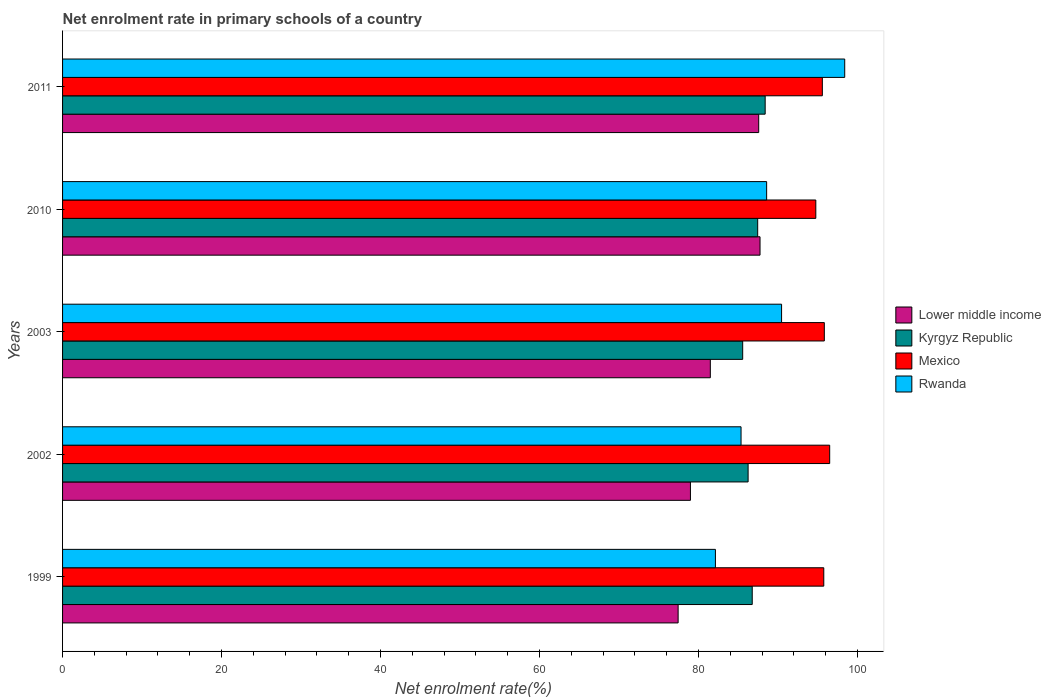Are the number of bars on each tick of the Y-axis equal?
Give a very brief answer. Yes. How many bars are there on the 5th tick from the top?
Keep it short and to the point. 4. How many bars are there on the 4th tick from the bottom?
Keep it short and to the point. 4. What is the label of the 1st group of bars from the top?
Keep it short and to the point. 2011. What is the net enrolment rate in primary schools in Rwanda in 2010?
Offer a very short reply. 88.57. Across all years, what is the maximum net enrolment rate in primary schools in Lower middle income?
Provide a short and direct response. 87.74. Across all years, what is the minimum net enrolment rate in primary schools in Lower middle income?
Keep it short and to the point. 77.44. In which year was the net enrolment rate in primary schools in Kyrgyz Republic maximum?
Ensure brevity in your answer.  2011. What is the total net enrolment rate in primary schools in Kyrgyz Republic in the graph?
Your answer should be very brief. 434.4. What is the difference between the net enrolment rate in primary schools in Kyrgyz Republic in 1999 and that in 2002?
Your response must be concise. 0.52. What is the difference between the net enrolment rate in primary schools in Rwanda in 1999 and the net enrolment rate in primary schools in Mexico in 2003?
Make the answer very short. -13.7. What is the average net enrolment rate in primary schools in Kyrgyz Republic per year?
Keep it short and to the point. 86.88. In the year 1999, what is the difference between the net enrolment rate in primary schools in Mexico and net enrolment rate in primary schools in Kyrgyz Republic?
Keep it short and to the point. 9. What is the ratio of the net enrolment rate in primary schools in Mexico in 1999 to that in 2010?
Make the answer very short. 1.01. Is the difference between the net enrolment rate in primary schools in Mexico in 2003 and 2011 greater than the difference between the net enrolment rate in primary schools in Kyrgyz Republic in 2003 and 2011?
Your answer should be compact. Yes. What is the difference between the highest and the second highest net enrolment rate in primary schools in Mexico?
Make the answer very short. 0.68. What is the difference between the highest and the lowest net enrolment rate in primary schools in Rwanda?
Give a very brief answer. 16.26. In how many years, is the net enrolment rate in primary schools in Lower middle income greater than the average net enrolment rate in primary schools in Lower middle income taken over all years?
Give a very brief answer. 2. What does the 1st bar from the top in 2010 represents?
Ensure brevity in your answer.  Rwanda. What does the 3rd bar from the bottom in 2003 represents?
Offer a terse response. Mexico. Are all the bars in the graph horizontal?
Offer a very short reply. Yes. What is the difference between two consecutive major ticks on the X-axis?
Give a very brief answer. 20. Does the graph contain grids?
Offer a terse response. No. Where does the legend appear in the graph?
Offer a terse response. Center right. How many legend labels are there?
Offer a very short reply. 4. How are the legend labels stacked?
Provide a short and direct response. Vertical. What is the title of the graph?
Offer a very short reply. Net enrolment rate in primary schools of a country. What is the label or title of the X-axis?
Your answer should be compact. Net enrolment rate(%). What is the label or title of the Y-axis?
Your answer should be compact. Years. What is the Net enrolment rate(%) in Lower middle income in 1999?
Ensure brevity in your answer.  77.44. What is the Net enrolment rate(%) of Kyrgyz Republic in 1999?
Ensure brevity in your answer.  86.76. What is the Net enrolment rate(%) of Mexico in 1999?
Offer a terse response. 95.76. What is the Net enrolment rate(%) in Rwanda in 1999?
Provide a short and direct response. 82.13. What is the Net enrolment rate(%) in Lower middle income in 2002?
Your response must be concise. 78.99. What is the Net enrolment rate(%) in Kyrgyz Republic in 2002?
Your response must be concise. 86.24. What is the Net enrolment rate(%) in Mexico in 2002?
Your response must be concise. 96.51. What is the Net enrolment rate(%) in Rwanda in 2002?
Offer a very short reply. 85.35. What is the Net enrolment rate(%) in Lower middle income in 2003?
Provide a succinct answer. 81.49. What is the Net enrolment rate(%) of Kyrgyz Republic in 2003?
Give a very brief answer. 85.56. What is the Net enrolment rate(%) in Mexico in 2003?
Give a very brief answer. 95.83. What is the Net enrolment rate(%) in Rwanda in 2003?
Your answer should be compact. 90.45. What is the Net enrolment rate(%) of Lower middle income in 2010?
Offer a very short reply. 87.74. What is the Net enrolment rate(%) in Kyrgyz Republic in 2010?
Ensure brevity in your answer.  87.45. What is the Net enrolment rate(%) in Mexico in 2010?
Ensure brevity in your answer.  94.76. What is the Net enrolment rate(%) of Rwanda in 2010?
Your answer should be very brief. 88.57. What is the Net enrolment rate(%) in Lower middle income in 2011?
Your answer should be very brief. 87.57. What is the Net enrolment rate(%) of Kyrgyz Republic in 2011?
Provide a succinct answer. 88.39. What is the Net enrolment rate(%) of Mexico in 2011?
Your response must be concise. 95.58. What is the Net enrolment rate(%) of Rwanda in 2011?
Keep it short and to the point. 98.39. Across all years, what is the maximum Net enrolment rate(%) in Lower middle income?
Your answer should be very brief. 87.74. Across all years, what is the maximum Net enrolment rate(%) in Kyrgyz Republic?
Keep it short and to the point. 88.39. Across all years, what is the maximum Net enrolment rate(%) in Mexico?
Provide a succinct answer. 96.51. Across all years, what is the maximum Net enrolment rate(%) in Rwanda?
Ensure brevity in your answer.  98.39. Across all years, what is the minimum Net enrolment rate(%) in Lower middle income?
Offer a very short reply. 77.44. Across all years, what is the minimum Net enrolment rate(%) of Kyrgyz Republic?
Make the answer very short. 85.56. Across all years, what is the minimum Net enrolment rate(%) of Mexico?
Offer a very short reply. 94.76. Across all years, what is the minimum Net enrolment rate(%) in Rwanda?
Your answer should be very brief. 82.13. What is the total Net enrolment rate(%) in Lower middle income in the graph?
Offer a terse response. 413.23. What is the total Net enrolment rate(%) in Kyrgyz Republic in the graph?
Offer a very short reply. 434.4. What is the total Net enrolment rate(%) in Mexico in the graph?
Provide a short and direct response. 478.44. What is the total Net enrolment rate(%) of Rwanda in the graph?
Give a very brief answer. 444.91. What is the difference between the Net enrolment rate(%) of Lower middle income in 1999 and that in 2002?
Your answer should be compact. -1.55. What is the difference between the Net enrolment rate(%) of Kyrgyz Republic in 1999 and that in 2002?
Offer a very short reply. 0.52. What is the difference between the Net enrolment rate(%) in Mexico in 1999 and that in 2002?
Offer a terse response. -0.74. What is the difference between the Net enrolment rate(%) in Rwanda in 1999 and that in 2002?
Offer a terse response. -3.22. What is the difference between the Net enrolment rate(%) of Lower middle income in 1999 and that in 2003?
Offer a very short reply. -4.05. What is the difference between the Net enrolment rate(%) in Kyrgyz Republic in 1999 and that in 2003?
Keep it short and to the point. 1.2. What is the difference between the Net enrolment rate(%) in Mexico in 1999 and that in 2003?
Make the answer very short. -0.07. What is the difference between the Net enrolment rate(%) in Rwanda in 1999 and that in 2003?
Your answer should be very brief. -8.32. What is the difference between the Net enrolment rate(%) of Lower middle income in 1999 and that in 2010?
Your answer should be very brief. -10.3. What is the difference between the Net enrolment rate(%) of Kyrgyz Republic in 1999 and that in 2010?
Your answer should be very brief. -0.69. What is the difference between the Net enrolment rate(%) of Rwanda in 1999 and that in 2010?
Offer a terse response. -6.44. What is the difference between the Net enrolment rate(%) in Lower middle income in 1999 and that in 2011?
Your answer should be very brief. -10.14. What is the difference between the Net enrolment rate(%) in Kyrgyz Republic in 1999 and that in 2011?
Provide a succinct answer. -1.63. What is the difference between the Net enrolment rate(%) of Mexico in 1999 and that in 2011?
Offer a terse response. 0.18. What is the difference between the Net enrolment rate(%) in Rwanda in 1999 and that in 2011?
Offer a terse response. -16.26. What is the difference between the Net enrolment rate(%) in Lower middle income in 2002 and that in 2003?
Your answer should be very brief. -2.5. What is the difference between the Net enrolment rate(%) in Kyrgyz Republic in 2002 and that in 2003?
Your answer should be compact. 0.68. What is the difference between the Net enrolment rate(%) in Mexico in 2002 and that in 2003?
Provide a short and direct response. 0.68. What is the difference between the Net enrolment rate(%) of Rwanda in 2002 and that in 2003?
Offer a very short reply. -5.1. What is the difference between the Net enrolment rate(%) of Lower middle income in 2002 and that in 2010?
Your answer should be compact. -8.76. What is the difference between the Net enrolment rate(%) in Kyrgyz Republic in 2002 and that in 2010?
Ensure brevity in your answer.  -1.21. What is the difference between the Net enrolment rate(%) of Mexico in 2002 and that in 2010?
Give a very brief answer. 1.75. What is the difference between the Net enrolment rate(%) in Rwanda in 2002 and that in 2010?
Offer a terse response. -3.22. What is the difference between the Net enrolment rate(%) in Lower middle income in 2002 and that in 2011?
Your answer should be very brief. -8.59. What is the difference between the Net enrolment rate(%) in Kyrgyz Republic in 2002 and that in 2011?
Ensure brevity in your answer.  -2.15. What is the difference between the Net enrolment rate(%) in Mexico in 2002 and that in 2011?
Keep it short and to the point. 0.92. What is the difference between the Net enrolment rate(%) of Rwanda in 2002 and that in 2011?
Offer a very short reply. -13.04. What is the difference between the Net enrolment rate(%) of Lower middle income in 2003 and that in 2010?
Provide a succinct answer. -6.25. What is the difference between the Net enrolment rate(%) of Kyrgyz Republic in 2003 and that in 2010?
Your response must be concise. -1.89. What is the difference between the Net enrolment rate(%) of Mexico in 2003 and that in 2010?
Offer a terse response. 1.07. What is the difference between the Net enrolment rate(%) of Rwanda in 2003 and that in 2010?
Offer a very short reply. 1.88. What is the difference between the Net enrolment rate(%) in Lower middle income in 2003 and that in 2011?
Provide a short and direct response. -6.08. What is the difference between the Net enrolment rate(%) of Kyrgyz Republic in 2003 and that in 2011?
Keep it short and to the point. -2.83. What is the difference between the Net enrolment rate(%) in Mexico in 2003 and that in 2011?
Offer a terse response. 0.25. What is the difference between the Net enrolment rate(%) in Rwanda in 2003 and that in 2011?
Your answer should be very brief. -7.94. What is the difference between the Net enrolment rate(%) in Lower middle income in 2010 and that in 2011?
Provide a short and direct response. 0.17. What is the difference between the Net enrolment rate(%) of Kyrgyz Republic in 2010 and that in 2011?
Make the answer very short. -0.94. What is the difference between the Net enrolment rate(%) in Mexico in 2010 and that in 2011?
Offer a terse response. -0.82. What is the difference between the Net enrolment rate(%) of Rwanda in 2010 and that in 2011?
Make the answer very short. -9.82. What is the difference between the Net enrolment rate(%) of Lower middle income in 1999 and the Net enrolment rate(%) of Kyrgyz Republic in 2002?
Provide a short and direct response. -8.8. What is the difference between the Net enrolment rate(%) in Lower middle income in 1999 and the Net enrolment rate(%) in Mexico in 2002?
Your answer should be compact. -19.07. What is the difference between the Net enrolment rate(%) in Lower middle income in 1999 and the Net enrolment rate(%) in Rwanda in 2002?
Offer a terse response. -7.92. What is the difference between the Net enrolment rate(%) of Kyrgyz Republic in 1999 and the Net enrolment rate(%) of Mexico in 2002?
Your answer should be compact. -9.74. What is the difference between the Net enrolment rate(%) of Kyrgyz Republic in 1999 and the Net enrolment rate(%) of Rwanda in 2002?
Your response must be concise. 1.41. What is the difference between the Net enrolment rate(%) in Mexico in 1999 and the Net enrolment rate(%) in Rwanda in 2002?
Make the answer very short. 10.41. What is the difference between the Net enrolment rate(%) in Lower middle income in 1999 and the Net enrolment rate(%) in Kyrgyz Republic in 2003?
Keep it short and to the point. -8.12. What is the difference between the Net enrolment rate(%) in Lower middle income in 1999 and the Net enrolment rate(%) in Mexico in 2003?
Keep it short and to the point. -18.39. What is the difference between the Net enrolment rate(%) in Lower middle income in 1999 and the Net enrolment rate(%) in Rwanda in 2003?
Make the answer very short. -13.01. What is the difference between the Net enrolment rate(%) of Kyrgyz Republic in 1999 and the Net enrolment rate(%) of Mexico in 2003?
Make the answer very short. -9.07. What is the difference between the Net enrolment rate(%) in Kyrgyz Republic in 1999 and the Net enrolment rate(%) in Rwanda in 2003?
Provide a short and direct response. -3.69. What is the difference between the Net enrolment rate(%) of Mexico in 1999 and the Net enrolment rate(%) of Rwanda in 2003?
Offer a very short reply. 5.31. What is the difference between the Net enrolment rate(%) of Lower middle income in 1999 and the Net enrolment rate(%) of Kyrgyz Republic in 2010?
Offer a terse response. -10.01. What is the difference between the Net enrolment rate(%) in Lower middle income in 1999 and the Net enrolment rate(%) in Mexico in 2010?
Keep it short and to the point. -17.32. What is the difference between the Net enrolment rate(%) of Lower middle income in 1999 and the Net enrolment rate(%) of Rwanda in 2010?
Offer a very short reply. -11.13. What is the difference between the Net enrolment rate(%) of Kyrgyz Republic in 1999 and the Net enrolment rate(%) of Mexico in 2010?
Your answer should be very brief. -8. What is the difference between the Net enrolment rate(%) of Kyrgyz Republic in 1999 and the Net enrolment rate(%) of Rwanda in 2010?
Keep it short and to the point. -1.81. What is the difference between the Net enrolment rate(%) of Mexico in 1999 and the Net enrolment rate(%) of Rwanda in 2010?
Your answer should be very brief. 7.19. What is the difference between the Net enrolment rate(%) in Lower middle income in 1999 and the Net enrolment rate(%) in Kyrgyz Republic in 2011?
Provide a short and direct response. -10.95. What is the difference between the Net enrolment rate(%) in Lower middle income in 1999 and the Net enrolment rate(%) in Mexico in 2011?
Give a very brief answer. -18.14. What is the difference between the Net enrolment rate(%) of Lower middle income in 1999 and the Net enrolment rate(%) of Rwanda in 2011?
Make the answer very short. -20.96. What is the difference between the Net enrolment rate(%) in Kyrgyz Republic in 1999 and the Net enrolment rate(%) in Mexico in 2011?
Make the answer very short. -8.82. What is the difference between the Net enrolment rate(%) in Kyrgyz Republic in 1999 and the Net enrolment rate(%) in Rwanda in 2011?
Provide a succinct answer. -11.63. What is the difference between the Net enrolment rate(%) of Mexico in 1999 and the Net enrolment rate(%) of Rwanda in 2011?
Offer a very short reply. -2.63. What is the difference between the Net enrolment rate(%) in Lower middle income in 2002 and the Net enrolment rate(%) in Kyrgyz Republic in 2003?
Ensure brevity in your answer.  -6.57. What is the difference between the Net enrolment rate(%) of Lower middle income in 2002 and the Net enrolment rate(%) of Mexico in 2003?
Provide a short and direct response. -16.84. What is the difference between the Net enrolment rate(%) in Lower middle income in 2002 and the Net enrolment rate(%) in Rwanda in 2003?
Keep it short and to the point. -11.47. What is the difference between the Net enrolment rate(%) of Kyrgyz Republic in 2002 and the Net enrolment rate(%) of Mexico in 2003?
Your response must be concise. -9.59. What is the difference between the Net enrolment rate(%) of Kyrgyz Republic in 2002 and the Net enrolment rate(%) of Rwanda in 2003?
Offer a very short reply. -4.21. What is the difference between the Net enrolment rate(%) in Mexico in 2002 and the Net enrolment rate(%) in Rwanda in 2003?
Make the answer very short. 6.05. What is the difference between the Net enrolment rate(%) of Lower middle income in 2002 and the Net enrolment rate(%) of Kyrgyz Republic in 2010?
Your answer should be compact. -8.46. What is the difference between the Net enrolment rate(%) in Lower middle income in 2002 and the Net enrolment rate(%) in Mexico in 2010?
Provide a succinct answer. -15.77. What is the difference between the Net enrolment rate(%) in Lower middle income in 2002 and the Net enrolment rate(%) in Rwanda in 2010?
Make the answer very short. -9.59. What is the difference between the Net enrolment rate(%) of Kyrgyz Republic in 2002 and the Net enrolment rate(%) of Mexico in 2010?
Your response must be concise. -8.52. What is the difference between the Net enrolment rate(%) of Kyrgyz Republic in 2002 and the Net enrolment rate(%) of Rwanda in 2010?
Make the answer very short. -2.33. What is the difference between the Net enrolment rate(%) of Mexico in 2002 and the Net enrolment rate(%) of Rwanda in 2010?
Keep it short and to the point. 7.93. What is the difference between the Net enrolment rate(%) in Lower middle income in 2002 and the Net enrolment rate(%) in Kyrgyz Republic in 2011?
Your answer should be very brief. -9.4. What is the difference between the Net enrolment rate(%) of Lower middle income in 2002 and the Net enrolment rate(%) of Mexico in 2011?
Your response must be concise. -16.59. What is the difference between the Net enrolment rate(%) in Lower middle income in 2002 and the Net enrolment rate(%) in Rwanda in 2011?
Provide a succinct answer. -19.41. What is the difference between the Net enrolment rate(%) in Kyrgyz Republic in 2002 and the Net enrolment rate(%) in Mexico in 2011?
Your response must be concise. -9.34. What is the difference between the Net enrolment rate(%) of Kyrgyz Republic in 2002 and the Net enrolment rate(%) of Rwanda in 2011?
Your answer should be very brief. -12.15. What is the difference between the Net enrolment rate(%) of Mexico in 2002 and the Net enrolment rate(%) of Rwanda in 2011?
Make the answer very short. -1.89. What is the difference between the Net enrolment rate(%) in Lower middle income in 2003 and the Net enrolment rate(%) in Kyrgyz Republic in 2010?
Keep it short and to the point. -5.96. What is the difference between the Net enrolment rate(%) in Lower middle income in 2003 and the Net enrolment rate(%) in Mexico in 2010?
Your response must be concise. -13.27. What is the difference between the Net enrolment rate(%) in Lower middle income in 2003 and the Net enrolment rate(%) in Rwanda in 2010?
Your response must be concise. -7.08. What is the difference between the Net enrolment rate(%) of Kyrgyz Republic in 2003 and the Net enrolment rate(%) of Mexico in 2010?
Your answer should be very brief. -9.2. What is the difference between the Net enrolment rate(%) of Kyrgyz Republic in 2003 and the Net enrolment rate(%) of Rwanda in 2010?
Provide a short and direct response. -3.01. What is the difference between the Net enrolment rate(%) in Mexico in 2003 and the Net enrolment rate(%) in Rwanda in 2010?
Provide a succinct answer. 7.26. What is the difference between the Net enrolment rate(%) in Lower middle income in 2003 and the Net enrolment rate(%) in Kyrgyz Republic in 2011?
Your response must be concise. -6.9. What is the difference between the Net enrolment rate(%) in Lower middle income in 2003 and the Net enrolment rate(%) in Mexico in 2011?
Offer a terse response. -14.09. What is the difference between the Net enrolment rate(%) in Lower middle income in 2003 and the Net enrolment rate(%) in Rwanda in 2011?
Provide a succinct answer. -16.91. What is the difference between the Net enrolment rate(%) in Kyrgyz Republic in 2003 and the Net enrolment rate(%) in Mexico in 2011?
Your answer should be compact. -10.02. What is the difference between the Net enrolment rate(%) in Kyrgyz Republic in 2003 and the Net enrolment rate(%) in Rwanda in 2011?
Provide a short and direct response. -12.84. What is the difference between the Net enrolment rate(%) of Mexico in 2003 and the Net enrolment rate(%) of Rwanda in 2011?
Provide a short and direct response. -2.56. What is the difference between the Net enrolment rate(%) of Lower middle income in 2010 and the Net enrolment rate(%) of Kyrgyz Republic in 2011?
Your answer should be very brief. -0.65. What is the difference between the Net enrolment rate(%) in Lower middle income in 2010 and the Net enrolment rate(%) in Mexico in 2011?
Make the answer very short. -7.84. What is the difference between the Net enrolment rate(%) in Lower middle income in 2010 and the Net enrolment rate(%) in Rwanda in 2011?
Give a very brief answer. -10.65. What is the difference between the Net enrolment rate(%) in Kyrgyz Republic in 2010 and the Net enrolment rate(%) in Mexico in 2011?
Provide a short and direct response. -8.13. What is the difference between the Net enrolment rate(%) in Kyrgyz Republic in 2010 and the Net enrolment rate(%) in Rwanda in 2011?
Your response must be concise. -10.95. What is the difference between the Net enrolment rate(%) of Mexico in 2010 and the Net enrolment rate(%) of Rwanda in 2011?
Provide a short and direct response. -3.64. What is the average Net enrolment rate(%) in Lower middle income per year?
Your response must be concise. 82.65. What is the average Net enrolment rate(%) in Kyrgyz Republic per year?
Ensure brevity in your answer.  86.88. What is the average Net enrolment rate(%) in Mexico per year?
Your answer should be compact. 95.69. What is the average Net enrolment rate(%) in Rwanda per year?
Ensure brevity in your answer.  88.98. In the year 1999, what is the difference between the Net enrolment rate(%) of Lower middle income and Net enrolment rate(%) of Kyrgyz Republic?
Offer a terse response. -9.32. In the year 1999, what is the difference between the Net enrolment rate(%) in Lower middle income and Net enrolment rate(%) in Mexico?
Ensure brevity in your answer.  -18.32. In the year 1999, what is the difference between the Net enrolment rate(%) of Lower middle income and Net enrolment rate(%) of Rwanda?
Offer a very short reply. -4.69. In the year 1999, what is the difference between the Net enrolment rate(%) in Kyrgyz Republic and Net enrolment rate(%) in Mexico?
Provide a succinct answer. -9. In the year 1999, what is the difference between the Net enrolment rate(%) of Kyrgyz Republic and Net enrolment rate(%) of Rwanda?
Provide a succinct answer. 4.63. In the year 1999, what is the difference between the Net enrolment rate(%) of Mexico and Net enrolment rate(%) of Rwanda?
Provide a short and direct response. 13.63. In the year 2002, what is the difference between the Net enrolment rate(%) of Lower middle income and Net enrolment rate(%) of Kyrgyz Republic?
Your answer should be compact. -7.26. In the year 2002, what is the difference between the Net enrolment rate(%) of Lower middle income and Net enrolment rate(%) of Mexico?
Provide a short and direct response. -17.52. In the year 2002, what is the difference between the Net enrolment rate(%) of Lower middle income and Net enrolment rate(%) of Rwanda?
Your response must be concise. -6.37. In the year 2002, what is the difference between the Net enrolment rate(%) of Kyrgyz Republic and Net enrolment rate(%) of Mexico?
Ensure brevity in your answer.  -10.26. In the year 2002, what is the difference between the Net enrolment rate(%) in Kyrgyz Republic and Net enrolment rate(%) in Rwanda?
Keep it short and to the point. 0.89. In the year 2002, what is the difference between the Net enrolment rate(%) of Mexico and Net enrolment rate(%) of Rwanda?
Offer a very short reply. 11.15. In the year 2003, what is the difference between the Net enrolment rate(%) of Lower middle income and Net enrolment rate(%) of Kyrgyz Republic?
Offer a very short reply. -4.07. In the year 2003, what is the difference between the Net enrolment rate(%) in Lower middle income and Net enrolment rate(%) in Mexico?
Your answer should be compact. -14.34. In the year 2003, what is the difference between the Net enrolment rate(%) of Lower middle income and Net enrolment rate(%) of Rwanda?
Provide a succinct answer. -8.96. In the year 2003, what is the difference between the Net enrolment rate(%) in Kyrgyz Republic and Net enrolment rate(%) in Mexico?
Your answer should be very brief. -10.27. In the year 2003, what is the difference between the Net enrolment rate(%) in Kyrgyz Republic and Net enrolment rate(%) in Rwanda?
Ensure brevity in your answer.  -4.89. In the year 2003, what is the difference between the Net enrolment rate(%) in Mexico and Net enrolment rate(%) in Rwanda?
Make the answer very short. 5.38. In the year 2010, what is the difference between the Net enrolment rate(%) in Lower middle income and Net enrolment rate(%) in Kyrgyz Republic?
Provide a succinct answer. 0.29. In the year 2010, what is the difference between the Net enrolment rate(%) in Lower middle income and Net enrolment rate(%) in Mexico?
Your response must be concise. -7.02. In the year 2010, what is the difference between the Net enrolment rate(%) of Lower middle income and Net enrolment rate(%) of Rwanda?
Offer a terse response. -0.83. In the year 2010, what is the difference between the Net enrolment rate(%) in Kyrgyz Republic and Net enrolment rate(%) in Mexico?
Offer a terse response. -7.31. In the year 2010, what is the difference between the Net enrolment rate(%) in Kyrgyz Republic and Net enrolment rate(%) in Rwanda?
Keep it short and to the point. -1.13. In the year 2010, what is the difference between the Net enrolment rate(%) in Mexico and Net enrolment rate(%) in Rwanda?
Provide a short and direct response. 6.19. In the year 2011, what is the difference between the Net enrolment rate(%) in Lower middle income and Net enrolment rate(%) in Kyrgyz Republic?
Ensure brevity in your answer.  -0.81. In the year 2011, what is the difference between the Net enrolment rate(%) of Lower middle income and Net enrolment rate(%) of Mexico?
Keep it short and to the point. -8.01. In the year 2011, what is the difference between the Net enrolment rate(%) in Lower middle income and Net enrolment rate(%) in Rwanda?
Provide a short and direct response. -10.82. In the year 2011, what is the difference between the Net enrolment rate(%) of Kyrgyz Republic and Net enrolment rate(%) of Mexico?
Make the answer very short. -7.19. In the year 2011, what is the difference between the Net enrolment rate(%) of Kyrgyz Republic and Net enrolment rate(%) of Rwanda?
Provide a succinct answer. -10.01. In the year 2011, what is the difference between the Net enrolment rate(%) of Mexico and Net enrolment rate(%) of Rwanda?
Offer a terse response. -2.81. What is the ratio of the Net enrolment rate(%) in Lower middle income in 1999 to that in 2002?
Ensure brevity in your answer.  0.98. What is the ratio of the Net enrolment rate(%) of Kyrgyz Republic in 1999 to that in 2002?
Give a very brief answer. 1.01. What is the ratio of the Net enrolment rate(%) in Mexico in 1999 to that in 2002?
Provide a succinct answer. 0.99. What is the ratio of the Net enrolment rate(%) in Rwanda in 1999 to that in 2002?
Provide a short and direct response. 0.96. What is the ratio of the Net enrolment rate(%) of Lower middle income in 1999 to that in 2003?
Give a very brief answer. 0.95. What is the ratio of the Net enrolment rate(%) of Kyrgyz Republic in 1999 to that in 2003?
Give a very brief answer. 1.01. What is the ratio of the Net enrolment rate(%) of Rwanda in 1999 to that in 2003?
Your response must be concise. 0.91. What is the ratio of the Net enrolment rate(%) in Lower middle income in 1999 to that in 2010?
Provide a short and direct response. 0.88. What is the ratio of the Net enrolment rate(%) in Kyrgyz Republic in 1999 to that in 2010?
Make the answer very short. 0.99. What is the ratio of the Net enrolment rate(%) in Mexico in 1999 to that in 2010?
Provide a short and direct response. 1.01. What is the ratio of the Net enrolment rate(%) of Rwanda in 1999 to that in 2010?
Offer a terse response. 0.93. What is the ratio of the Net enrolment rate(%) in Lower middle income in 1999 to that in 2011?
Ensure brevity in your answer.  0.88. What is the ratio of the Net enrolment rate(%) in Kyrgyz Republic in 1999 to that in 2011?
Your answer should be compact. 0.98. What is the ratio of the Net enrolment rate(%) in Rwanda in 1999 to that in 2011?
Provide a succinct answer. 0.83. What is the ratio of the Net enrolment rate(%) in Lower middle income in 2002 to that in 2003?
Offer a terse response. 0.97. What is the ratio of the Net enrolment rate(%) in Rwanda in 2002 to that in 2003?
Offer a very short reply. 0.94. What is the ratio of the Net enrolment rate(%) in Lower middle income in 2002 to that in 2010?
Ensure brevity in your answer.  0.9. What is the ratio of the Net enrolment rate(%) in Kyrgyz Republic in 2002 to that in 2010?
Ensure brevity in your answer.  0.99. What is the ratio of the Net enrolment rate(%) of Mexico in 2002 to that in 2010?
Make the answer very short. 1.02. What is the ratio of the Net enrolment rate(%) of Rwanda in 2002 to that in 2010?
Offer a very short reply. 0.96. What is the ratio of the Net enrolment rate(%) of Lower middle income in 2002 to that in 2011?
Your answer should be compact. 0.9. What is the ratio of the Net enrolment rate(%) in Kyrgyz Republic in 2002 to that in 2011?
Provide a succinct answer. 0.98. What is the ratio of the Net enrolment rate(%) of Mexico in 2002 to that in 2011?
Offer a very short reply. 1.01. What is the ratio of the Net enrolment rate(%) of Rwanda in 2002 to that in 2011?
Your answer should be very brief. 0.87. What is the ratio of the Net enrolment rate(%) of Lower middle income in 2003 to that in 2010?
Offer a terse response. 0.93. What is the ratio of the Net enrolment rate(%) in Kyrgyz Republic in 2003 to that in 2010?
Your answer should be very brief. 0.98. What is the ratio of the Net enrolment rate(%) of Mexico in 2003 to that in 2010?
Offer a terse response. 1.01. What is the ratio of the Net enrolment rate(%) in Rwanda in 2003 to that in 2010?
Ensure brevity in your answer.  1.02. What is the ratio of the Net enrolment rate(%) of Lower middle income in 2003 to that in 2011?
Provide a short and direct response. 0.93. What is the ratio of the Net enrolment rate(%) in Rwanda in 2003 to that in 2011?
Keep it short and to the point. 0.92. What is the ratio of the Net enrolment rate(%) of Lower middle income in 2010 to that in 2011?
Ensure brevity in your answer.  1. What is the ratio of the Net enrolment rate(%) in Kyrgyz Republic in 2010 to that in 2011?
Your answer should be very brief. 0.99. What is the ratio of the Net enrolment rate(%) in Rwanda in 2010 to that in 2011?
Provide a short and direct response. 0.9. What is the difference between the highest and the second highest Net enrolment rate(%) in Lower middle income?
Your answer should be very brief. 0.17. What is the difference between the highest and the second highest Net enrolment rate(%) of Kyrgyz Republic?
Your answer should be compact. 0.94. What is the difference between the highest and the second highest Net enrolment rate(%) of Mexico?
Your answer should be very brief. 0.68. What is the difference between the highest and the second highest Net enrolment rate(%) of Rwanda?
Offer a very short reply. 7.94. What is the difference between the highest and the lowest Net enrolment rate(%) of Lower middle income?
Your answer should be very brief. 10.3. What is the difference between the highest and the lowest Net enrolment rate(%) in Kyrgyz Republic?
Your answer should be very brief. 2.83. What is the difference between the highest and the lowest Net enrolment rate(%) of Mexico?
Keep it short and to the point. 1.75. What is the difference between the highest and the lowest Net enrolment rate(%) of Rwanda?
Offer a terse response. 16.26. 